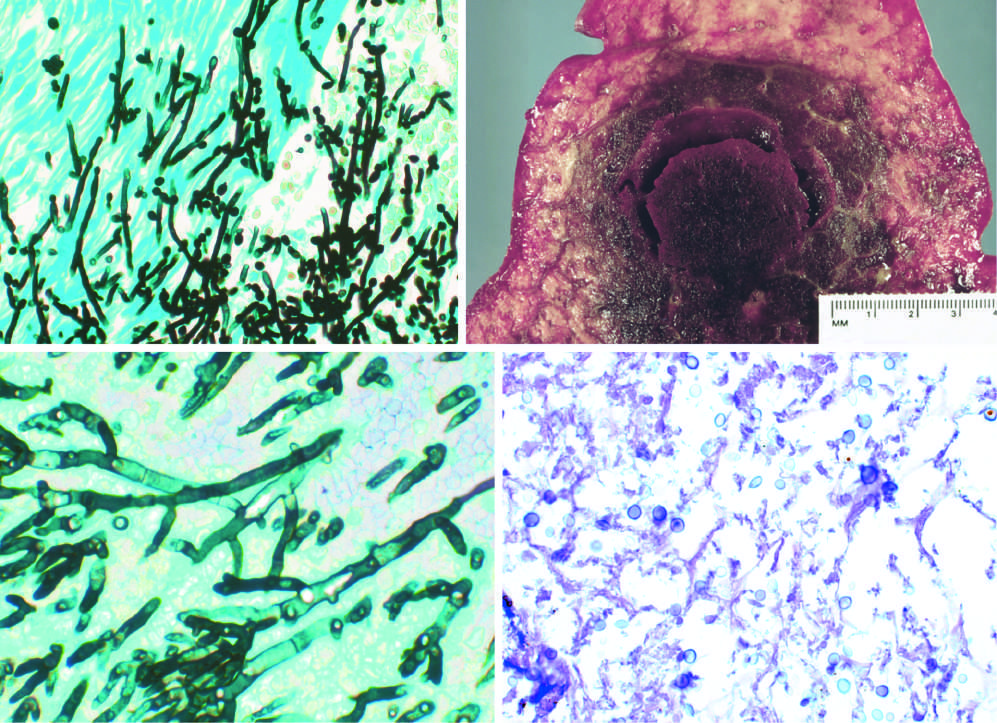do small nests of epithelial cells and myxoid stroma forming cartilage and bone show septate hyphae with acute-angle branching, consistent with aspergillus?
Answer the question using a single word or phrase. No 